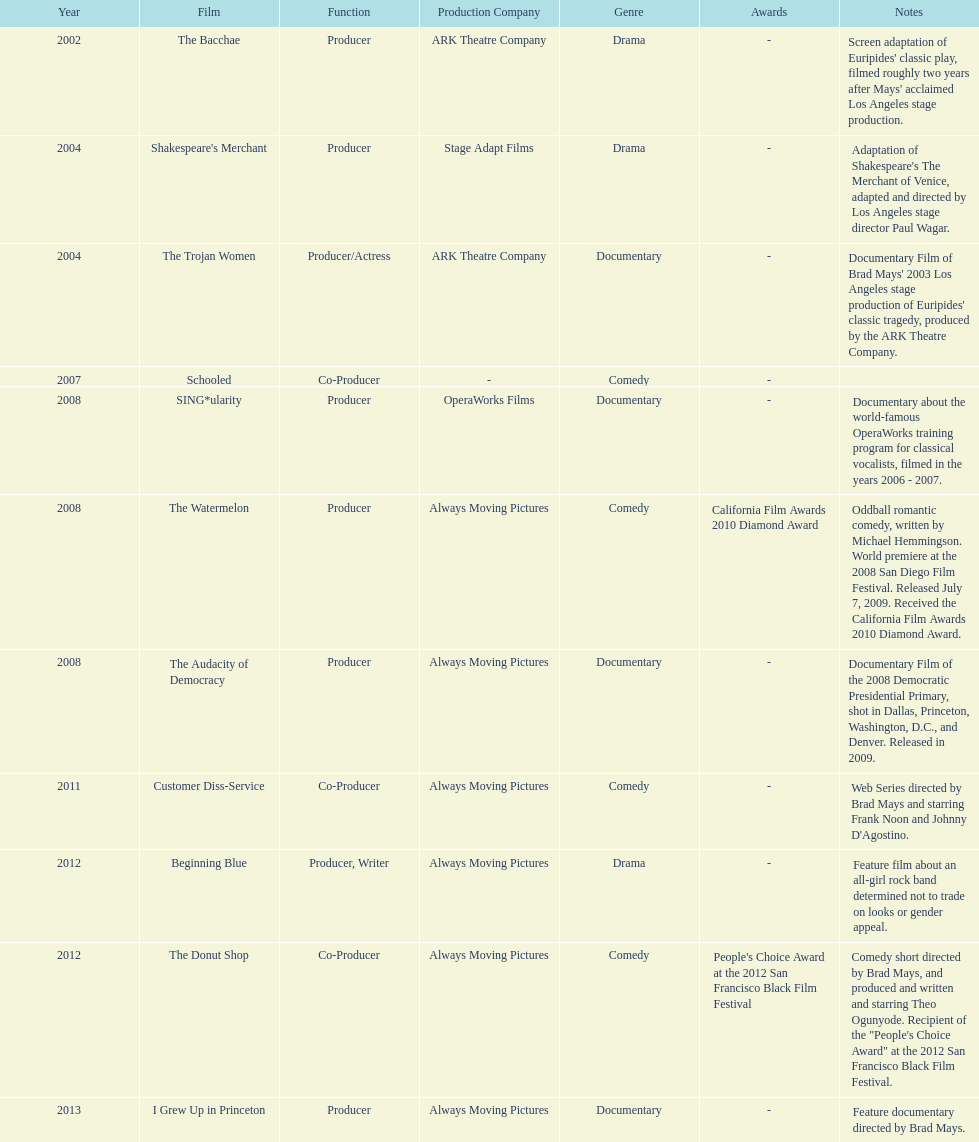Give me the full table as a dictionary. {'header': ['Year', 'Film', 'Function', 'Production Company', 'Genre', 'Awards', 'Notes'], 'rows': [['2002', 'The Bacchae', 'Producer', 'ARK Theatre Company', 'Drama', '-', "Screen adaptation of Euripides' classic play, filmed roughly two years after Mays' acclaimed Los Angeles stage production."], ['2004', "Shakespeare's Merchant", 'Producer', 'Stage Adapt Films', 'Drama', '-', "Adaptation of Shakespeare's The Merchant of Venice, adapted and directed by Los Angeles stage director Paul Wagar."], ['2004', 'The Trojan Women', 'Producer/Actress', 'ARK Theatre Company', 'Documentary', '-', "Documentary Film of Brad Mays' 2003 Los Angeles stage production of Euripides' classic tragedy, produced by the ARK Theatre Company."], ['2007', 'Schooled', 'Co-Producer', '-', 'Comedy', '-', ''], ['2008', 'SING*ularity', 'Producer', 'OperaWorks Films', 'Documentary', '-', 'Documentary about the world-famous OperaWorks training program for classical vocalists, filmed in the years 2006 - 2007.'], ['2008', 'The Watermelon', 'Producer', 'Always Moving Pictures', 'Comedy', 'California Film Awards 2010 Diamond Award', 'Oddball romantic comedy, written by Michael Hemmingson. World premiere at the 2008 San Diego Film Festival. Released July 7, 2009. Received the California Film Awards 2010 Diamond Award.'], ['2008', 'The Audacity of Democracy', 'Producer', 'Always Moving Pictures', 'Documentary', '-', 'Documentary Film of the 2008 Democratic Presidential Primary, shot in Dallas, Princeton, Washington, D.C., and Denver. Released in 2009.'], ['2011', 'Customer Diss-Service', 'Co-Producer', 'Always Moving Pictures', 'Comedy', '-', "Web Series directed by Brad Mays and starring Frank Noon and Johnny D'Agostino."], ['2012', 'Beginning Blue', 'Producer, Writer', 'Always Moving Pictures', 'Drama', '-', 'Feature film about an all-girl rock band determined not to trade on looks or gender appeal.'], ['2012', 'The Donut Shop', 'Co-Producer', 'Always Moving Pictures', 'Comedy', "People's Choice Award at the 2012 San Francisco Black Film Festival", 'Comedy short directed by Brad Mays, and produced and written and starring Theo Ogunyode. Recipient of the "People\'s Choice Award" at the 2012 San Francisco Black Film Festival.'], ['2013', 'I Grew Up in Princeton', 'Producer', 'Always Moving Pictures', 'Documentary', '-', 'Feature documentary directed by Brad Mays.']]} How many films did ms. starfelt produce after 2010? 4. 